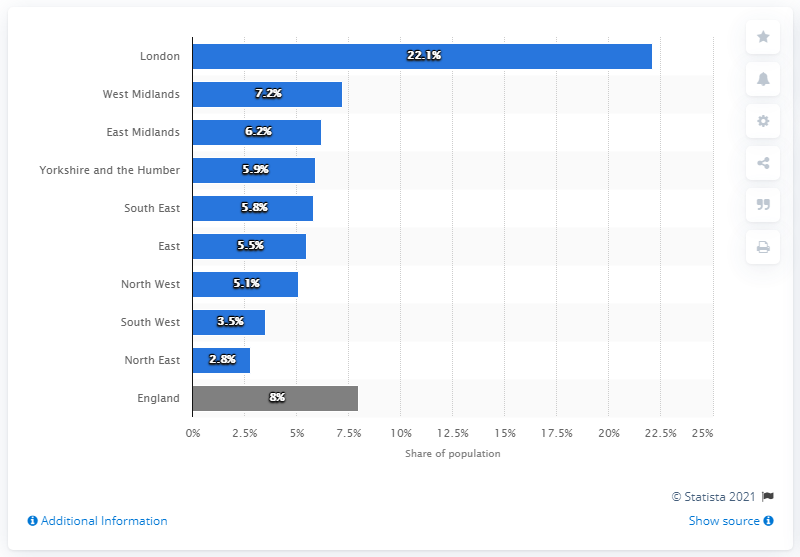Identify some key points in this picture. According to the data, the West Midlands region had the highest percentage of people who stated that English was not their main language. 